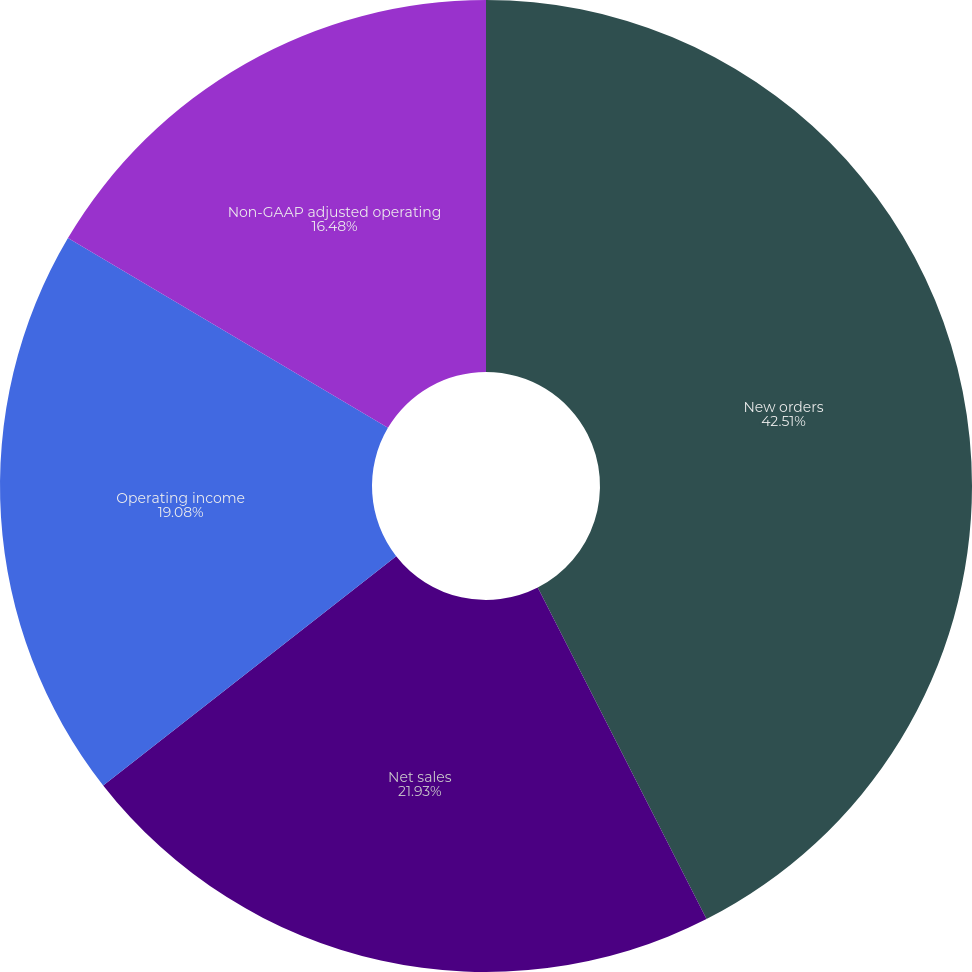Convert chart to OTSL. <chart><loc_0><loc_0><loc_500><loc_500><pie_chart><fcel>New orders<fcel>Net sales<fcel>Operating income<fcel>Non-GAAP adjusted operating<nl><fcel>42.5%<fcel>21.93%<fcel>19.08%<fcel>16.48%<nl></chart> 